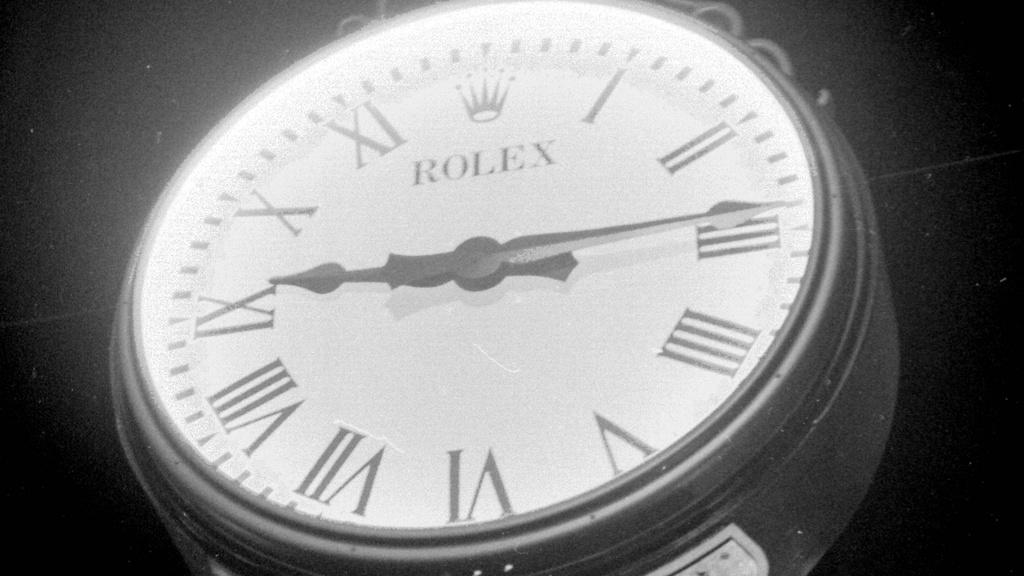What brand of watch is this?
Keep it short and to the point. Rolex. What time is shown?
Ensure brevity in your answer.  9:15. 